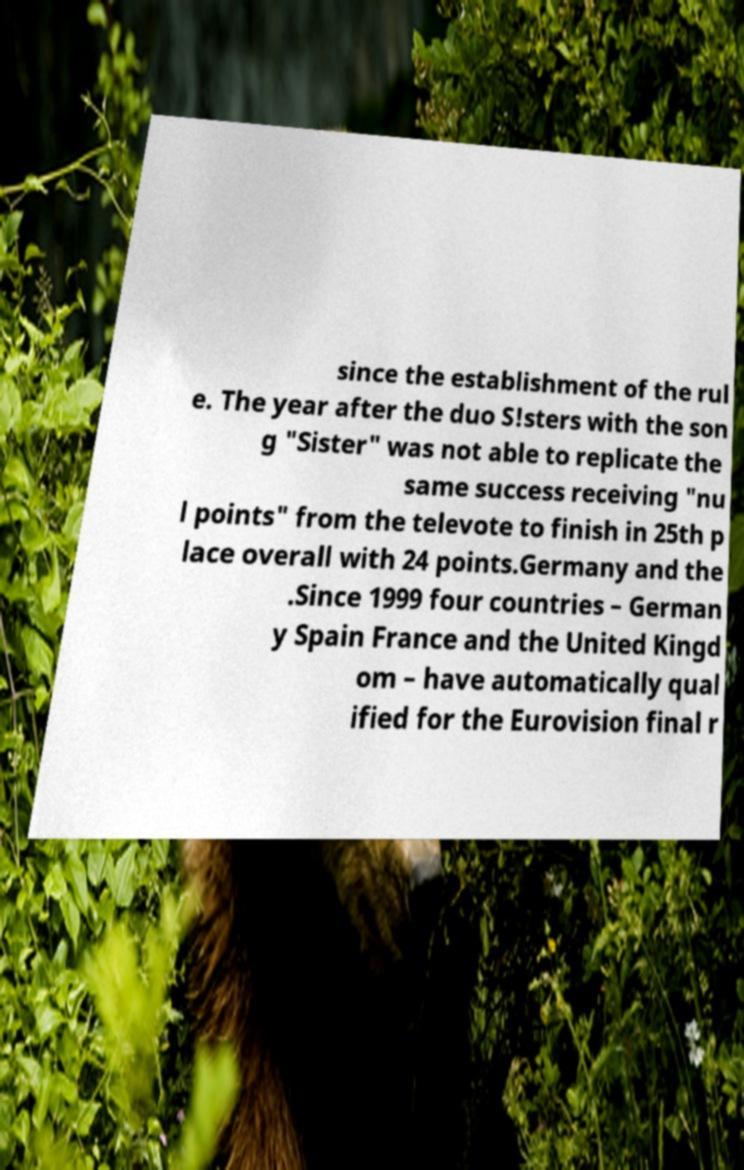For documentation purposes, I need the text within this image transcribed. Could you provide that? since the establishment of the rul e. The year after the duo S!sters with the son g "Sister" was not able to replicate the same success receiving "nu l points" from the televote to finish in 25th p lace overall with 24 points.Germany and the .Since 1999 four countries – German y Spain France and the United Kingd om – have automatically qual ified for the Eurovision final r 